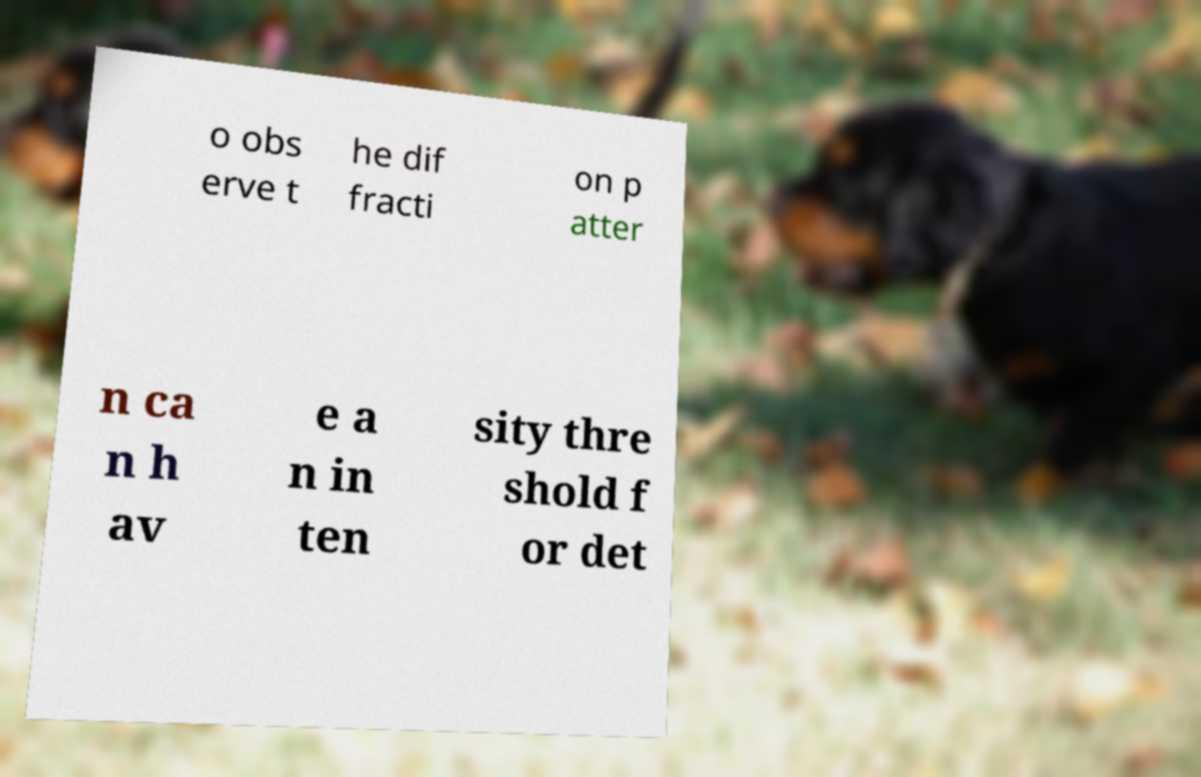Can you read and provide the text displayed in the image?This photo seems to have some interesting text. Can you extract and type it out for me? o obs erve t he dif fracti on p atter n ca n h av e a n in ten sity thre shold f or det 